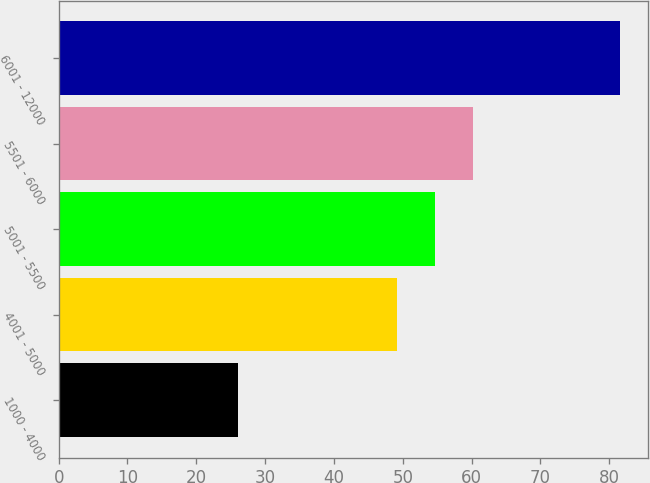<chart> <loc_0><loc_0><loc_500><loc_500><bar_chart><fcel>1000 - 4000<fcel>4001 - 5000<fcel>5001 - 5500<fcel>5501 - 6000<fcel>6001 - 12000<nl><fcel>26.04<fcel>49.15<fcel>54.7<fcel>60.25<fcel>81.5<nl></chart> 